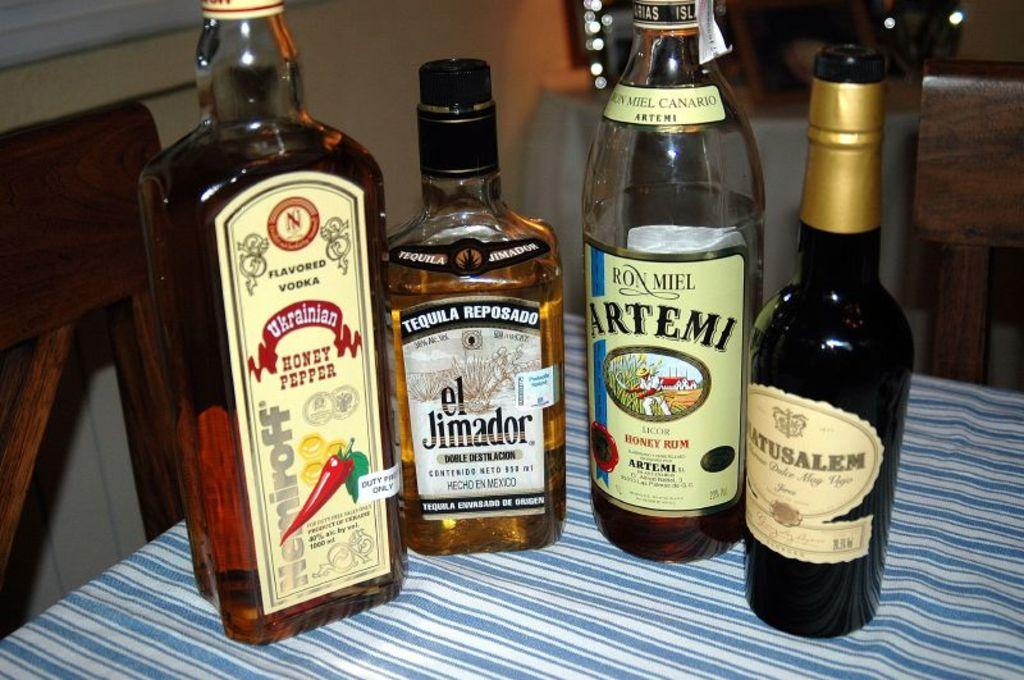<image>
Give a short and clear explanation of the subsequent image. A bottle of el Jimador sits on a striped tablecloth with some other bottles. 